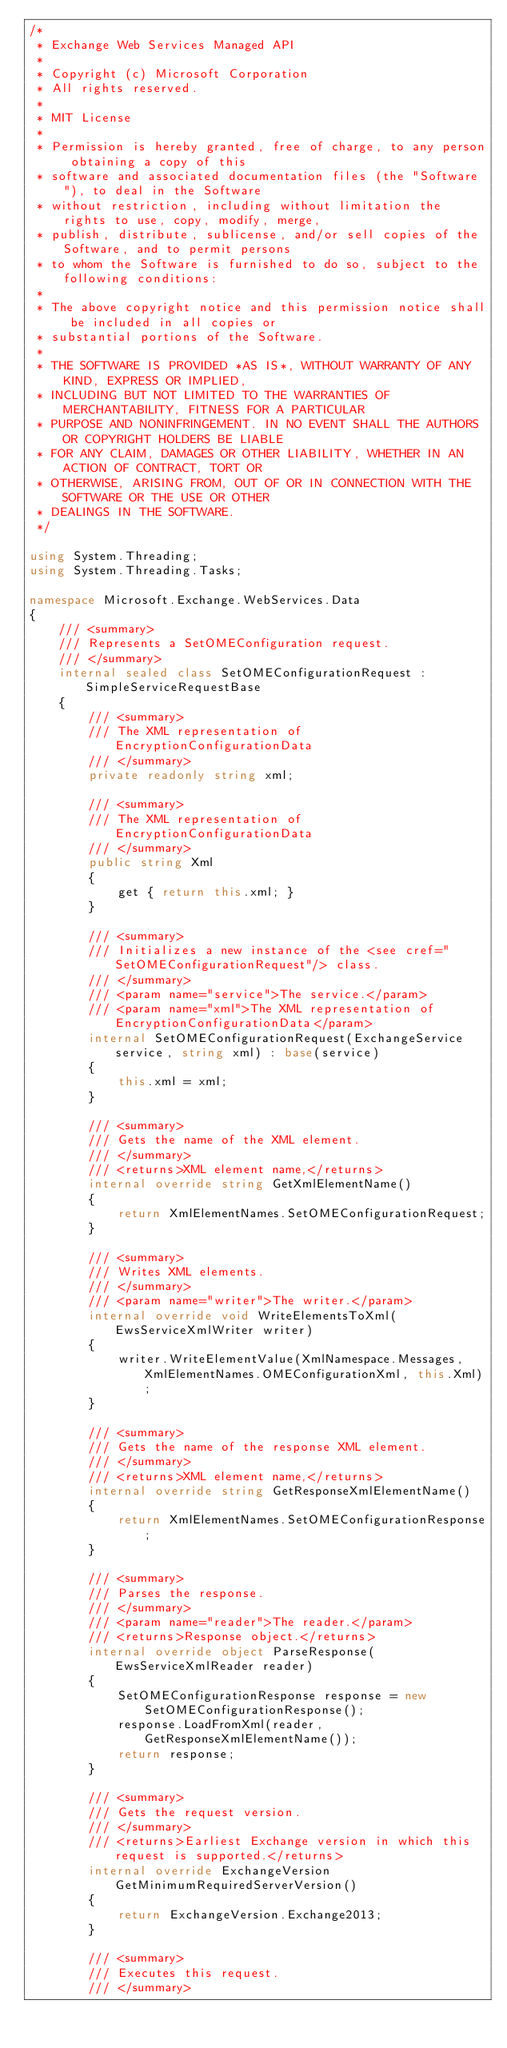Convert code to text. <code><loc_0><loc_0><loc_500><loc_500><_C#_>/*
 * Exchange Web Services Managed API
 *
 * Copyright (c) Microsoft Corporation
 * All rights reserved.
 *
 * MIT License
 *
 * Permission is hereby granted, free of charge, to any person obtaining a copy of this
 * software and associated documentation files (the "Software"), to deal in the Software
 * without restriction, including without limitation the rights to use, copy, modify, merge,
 * publish, distribute, sublicense, and/or sell copies of the Software, and to permit persons
 * to whom the Software is furnished to do so, subject to the following conditions:
 *
 * The above copyright notice and this permission notice shall be included in all copies or
 * substantial portions of the Software.
 *
 * THE SOFTWARE IS PROVIDED *AS IS*, WITHOUT WARRANTY OF ANY KIND, EXPRESS OR IMPLIED,
 * INCLUDING BUT NOT LIMITED TO THE WARRANTIES OF MERCHANTABILITY, FITNESS FOR A PARTICULAR
 * PURPOSE AND NONINFRINGEMENT. IN NO EVENT SHALL THE AUTHORS OR COPYRIGHT HOLDERS BE LIABLE
 * FOR ANY CLAIM, DAMAGES OR OTHER LIABILITY, WHETHER IN AN ACTION OF CONTRACT, TORT OR
 * OTHERWISE, ARISING FROM, OUT OF OR IN CONNECTION WITH THE SOFTWARE OR THE USE OR OTHER
 * DEALINGS IN THE SOFTWARE.
 */

using System.Threading;
using System.Threading.Tasks;

namespace Microsoft.Exchange.WebServices.Data
{
    /// <summary>
    /// Represents a SetOMEConfiguration request.
    /// </summary>
    internal sealed class SetOMEConfigurationRequest : SimpleServiceRequestBase
    {
        /// <summary>
        /// The XML representation of EncryptionConfigurationData
        /// </summary>
        private readonly string xml;

        /// <summary>
        /// The XML representation of EncryptionConfigurationData
        /// </summary>
        public string Xml
        {
            get { return this.xml; }
        }

        /// <summary>
        /// Initializes a new instance of the <see cref="SetOMEConfigurationRequest"/> class.
        /// </summary>
        /// <param name="service">The service.</param>
        /// <param name="xml">The XML representation of EncryptionConfigurationData</param>
        internal SetOMEConfigurationRequest(ExchangeService service, string xml) : base(service)
        {
            this.xml = xml;
        }

        /// <summary>
        /// Gets the name of the XML element.
        /// </summary>
        /// <returns>XML element name,</returns>
        internal override string GetXmlElementName()
        {
            return XmlElementNames.SetOMEConfigurationRequest;
        }

        /// <summary>
        /// Writes XML elements.
        /// </summary>
        /// <param name="writer">The writer.</param>
        internal override void WriteElementsToXml(EwsServiceXmlWriter writer)
        {
            writer.WriteElementValue(XmlNamespace.Messages, XmlElementNames.OMEConfigurationXml, this.Xml);
        }

        /// <summary>
        /// Gets the name of the response XML element.
        /// </summary>
        /// <returns>XML element name,</returns>
        internal override string GetResponseXmlElementName()
        {
            return XmlElementNames.SetOMEConfigurationResponse;
        }

        /// <summary>
        /// Parses the response.
        /// </summary>
        /// <param name="reader">The reader.</param>
        /// <returns>Response object.</returns>
        internal override object ParseResponse(EwsServiceXmlReader reader)
        {
            SetOMEConfigurationResponse response = new SetOMEConfigurationResponse();
            response.LoadFromXml(reader, GetResponseXmlElementName());
            return response;
        }

        /// <summary>
        /// Gets the request version.
        /// </summary>
        /// <returns>Earliest Exchange version in which this request is supported.</returns>
        internal override ExchangeVersion GetMinimumRequiredServerVersion()
        {
            return ExchangeVersion.Exchange2013;
        }

        /// <summary>
        /// Executes this request.
        /// </summary></code> 